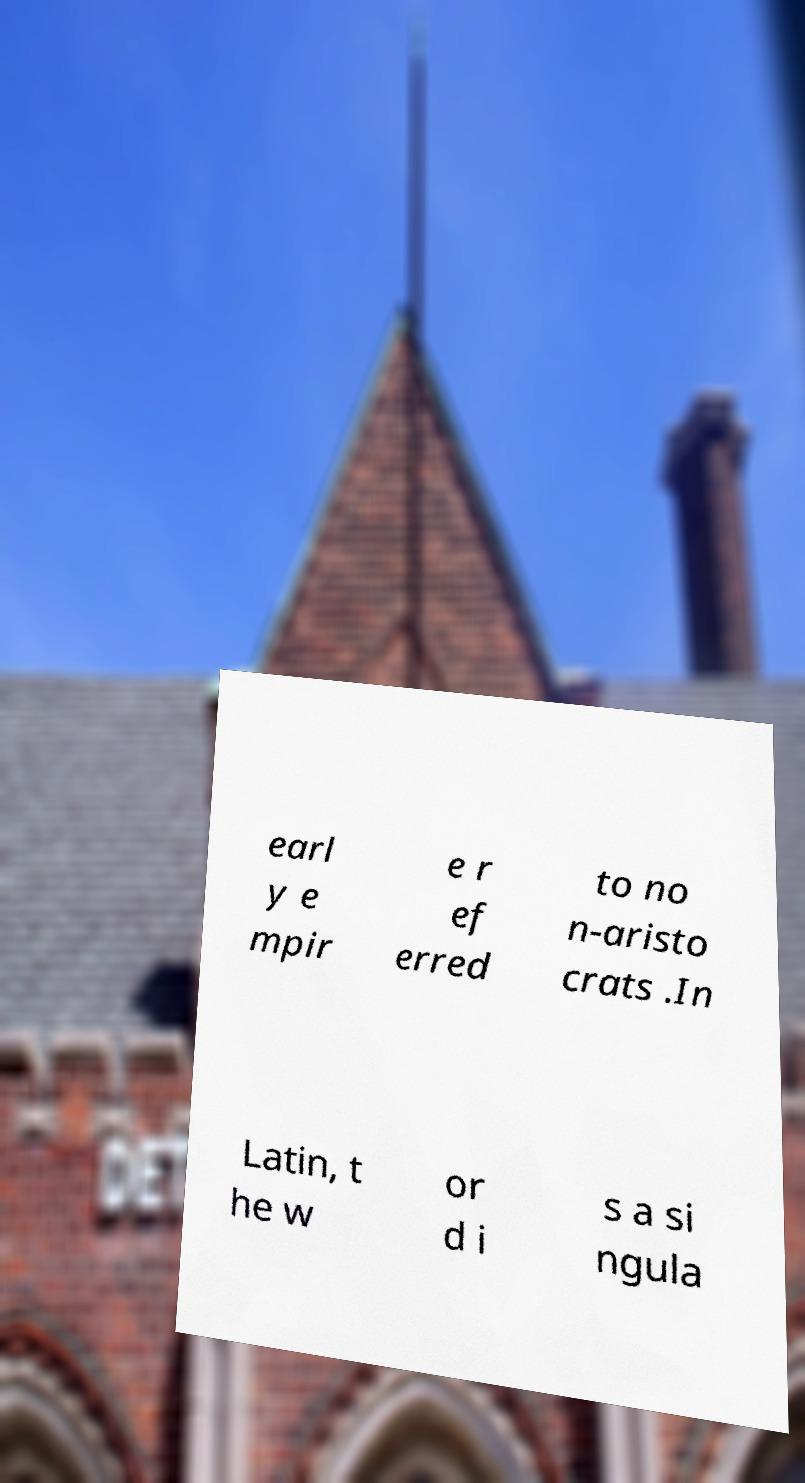Could you extract and type out the text from this image? earl y e mpir e r ef erred to no n-aristo crats .In Latin, t he w or d i s a si ngula 